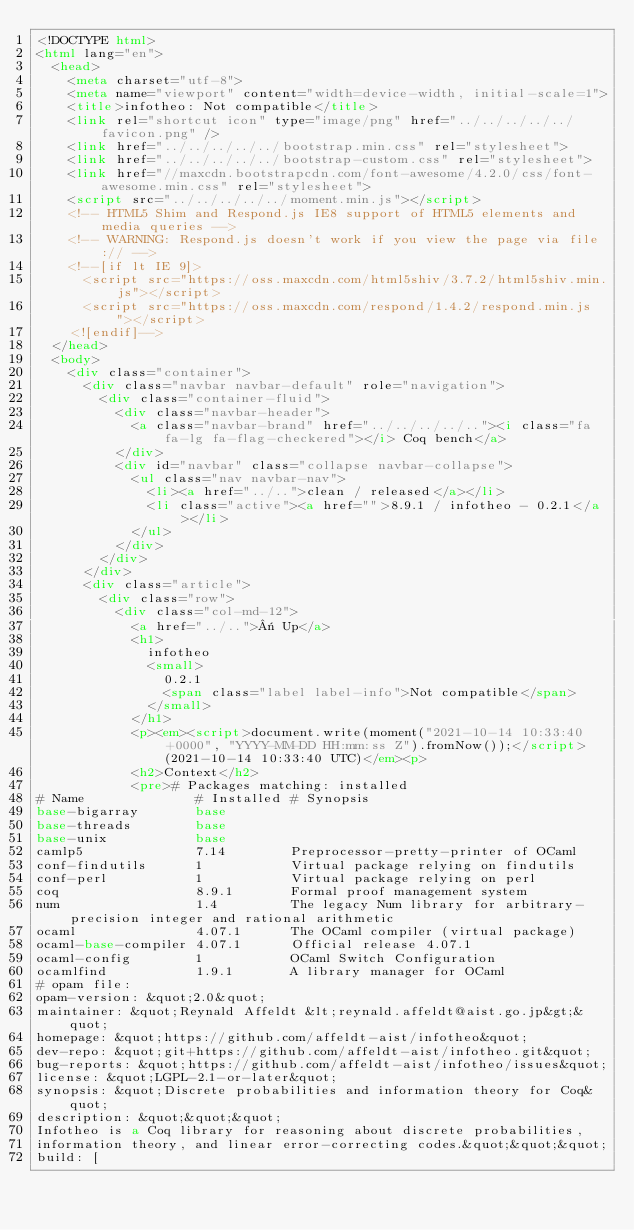Convert code to text. <code><loc_0><loc_0><loc_500><loc_500><_HTML_><!DOCTYPE html>
<html lang="en">
  <head>
    <meta charset="utf-8">
    <meta name="viewport" content="width=device-width, initial-scale=1">
    <title>infotheo: Not compatible</title>
    <link rel="shortcut icon" type="image/png" href="../../../../../favicon.png" />
    <link href="../../../../../bootstrap.min.css" rel="stylesheet">
    <link href="../../../../../bootstrap-custom.css" rel="stylesheet">
    <link href="//maxcdn.bootstrapcdn.com/font-awesome/4.2.0/css/font-awesome.min.css" rel="stylesheet">
    <script src="../../../../../moment.min.js"></script>
    <!-- HTML5 Shim and Respond.js IE8 support of HTML5 elements and media queries -->
    <!-- WARNING: Respond.js doesn't work if you view the page via file:// -->
    <!--[if lt IE 9]>
      <script src="https://oss.maxcdn.com/html5shiv/3.7.2/html5shiv.min.js"></script>
      <script src="https://oss.maxcdn.com/respond/1.4.2/respond.min.js"></script>
    <![endif]-->
  </head>
  <body>
    <div class="container">
      <div class="navbar navbar-default" role="navigation">
        <div class="container-fluid">
          <div class="navbar-header">
            <a class="navbar-brand" href="../../../../.."><i class="fa fa-lg fa-flag-checkered"></i> Coq bench</a>
          </div>
          <div id="navbar" class="collapse navbar-collapse">
            <ul class="nav navbar-nav">
              <li><a href="../..">clean / released</a></li>
              <li class="active"><a href="">8.9.1 / infotheo - 0.2.1</a></li>
            </ul>
          </div>
        </div>
      </div>
      <div class="article">
        <div class="row">
          <div class="col-md-12">
            <a href="../..">« Up</a>
            <h1>
              infotheo
              <small>
                0.2.1
                <span class="label label-info">Not compatible</span>
              </small>
            </h1>
            <p><em><script>document.write(moment("2021-10-14 10:33:40 +0000", "YYYY-MM-DD HH:mm:ss Z").fromNow());</script> (2021-10-14 10:33:40 UTC)</em><p>
            <h2>Context</h2>
            <pre># Packages matching: installed
# Name              # Installed # Synopsis
base-bigarray       base
base-threads        base
base-unix           base
camlp5              7.14        Preprocessor-pretty-printer of OCaml
conf-findutils      1           Virtual package relying on findutils
conf-perl           1           Virtual package relying on perl
coq                 8.9.1       Formal proof management system
num                 1.4         The legacy Num library for arbitrary-precision integer and rational arithmetic
ocaml               4.07.1      The OCaml compiler (virtual package)
ocaml-base-compiler 4.07.1      Official release 4.07.1
ocaml-config        1           OCaml Switch Configuration
ocamlfind           1.9.1       A library manager for OCaml
# opam file:
opam-version: &quot;2.0&quot;
maintainer: &quot;Reynald Affeldt &lt;reynald.affeldt@aist.go.jp&gt;&quot;
homepage: &quot;https://github.com/affeldt-aist/infotheo&quot;
dev-repo: &quot;git+https://github.com/affeldt-aist/infotheo.git&quot;
bug-reports: &quot;https://github.com/affeldt-aist/infotheo/issues&quot;
license: &quot;LGPL-2.1-or-later&quot;
synopsis: &quot;Discrete probabilities and information theory for Coq&quot;
description: &quot;&quot;&quot;
Infotheo is a Coq library for reasoning about discrete probabilities,
information theory, and linear error-correcting codes.&quot;&quot;&quot;
build: [</code> 